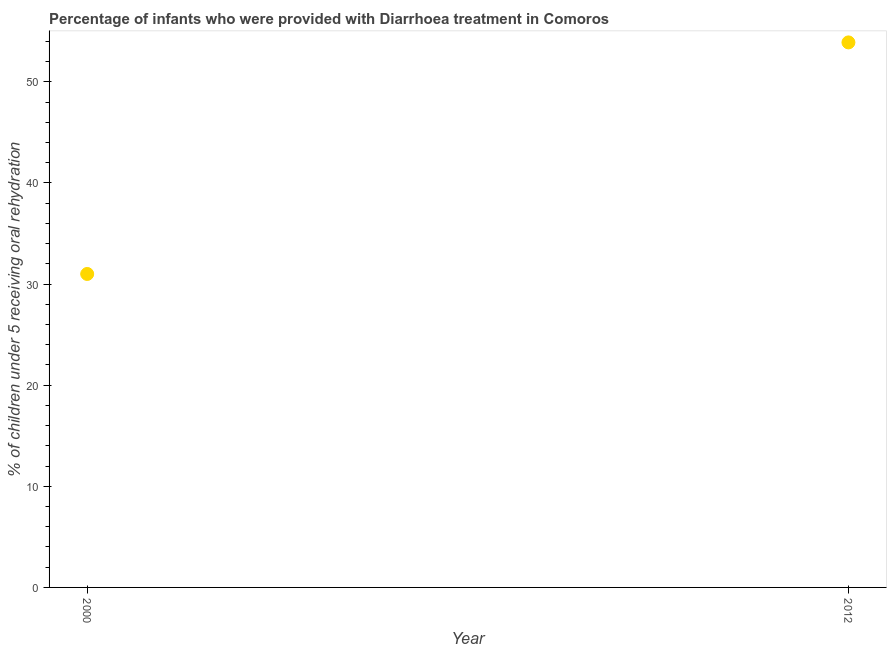What is the percentage of children who were provided with treatment diarrhoea in 2012?
Your response must be concise. 53.9. Across all years, what is the maximum percentage of children who were provided with treatment diarrhoea?
Give a very brief answer. 53.9. In which year was the percentage of children who were provided with treatment diarrhoea maximum?
Ensure brevity in your answer.  2012. What is the sum of the percentage of children who were provided with treatment diarrhoea?
Give a very brief answer. 84.9. What is the difference between the percentage of children who were provided with treatment diarrhoea in 2000 and 2012?
Offer a terse response. -22.9. What is the average percentage of children who were provided with treatment diarrhoea per year?
Your answer should be very brief. 42.45. What is the median percentage of children who were provided with treatment diarrhoea?
Your response must be concise. 42.45. In how many years, is the percentage of children who were provided with treatment diarrhoea greater than 12 %?
Give a very brief answer. 2. Do a majority of the years between 2012 and 2000 (inclusive) have percentage of children who were provided with treatment diarrhoea greater than 28 %?
Ensure brevity in your answer.  No. What is the ratio of the percentage of children who were provided with treatment diarrhoea in 2000 to that in 2012?
Offer a terse response. 0.58. In how many years, is the percentage of children who were provided with treatment diarrhoea greater than the average percentage of children who were provided with treatment diarrhoea taken over all years?
Give a very brief answer. 1. Does the percentage of children who were provided with treatment diarrhoea monotonically increase over the years?
Offer a terse response. Yes. Are the values on the major ticks of Y-axis written in scientific E-notation?
Offer a very short reply. No. Does the graph contain grids?
Your answer should be compact. No. What is the title of the graph?
Give a very brief answer. Percentage of infants who were provided with Diarrhoea treatment in Comoros. What is the label or title of the X-axis?
Provide a short and direct response. Year. What is the label or title of the Y-axis?
Make the answer very short. % of children under 5 receiving oral rehydration. What is the % of children under 5 receiving oral rehydration in 2012?
Make the answer very short. 53.9. What is the difference between the % of children under 5 receiving oral rehydration in 2000 and 2012?
Offer a very short reply. -22.9. What is the ratio of the % of children under 5 receiving oral rehydration in 2000 to that in 2012?
Offer a very short reply. 0.57. 